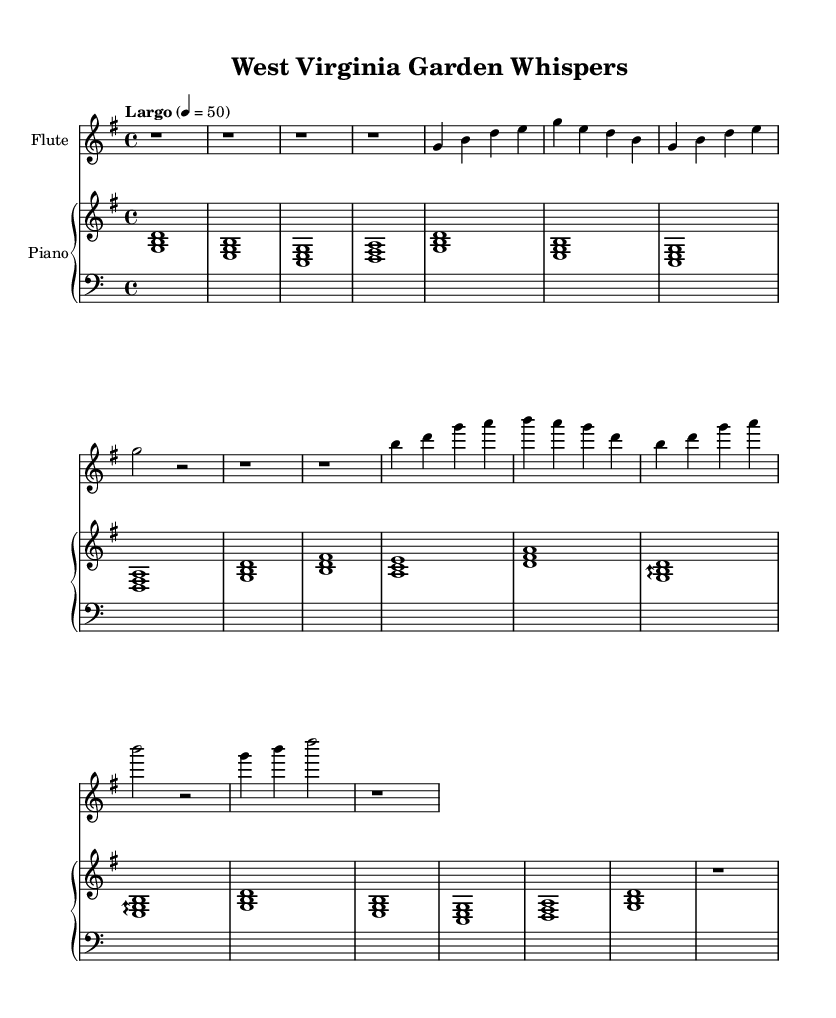What is the key signature of this music? The key signature is G major, which has one sharp (F#).
Answer: G major What is the time signature of the piece? The time signature is 4/4, which indicates four beats per measure.
Answer: 4/4 What is the tempo marking for this piece? The tempo marking is "Largo", which means to be performed slowly and broadly.
Answer: Largo How many main themes are present in the music? There are two main themes, labeled as Main Theme A and Main Theme B.
Answer: 2 Which instruments are featured in this score? The score features a flute and a piano.
Answer: Flute and piano What dynamic markings are suggested for the flute part? The flute part has no specific dynamic markings indicated, but it suggests a gentle playing style.
Answer: Gentle What is the purpose of the interlude in the music? The interlude serves as a transition between the two main themes, creating a calm atmosphere reminiscent of nature.
Answer: Calm transition 